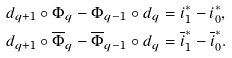<formula> <loc_0><loc_0><loc_500><loc_500>d _ { q + 1 } \circ \Phi _ { q } - \Phi _ { q - 1 } \circ d _ { q } & = i _ { 1 } ^ { \ast } - i _ { 0 } ^ { \ast } , \\ d _ { q + 1 } \circ \overline { \Phi } _ { q } - \overline { \Phi } _ { q - 1 } \circ d _ { q } & = \overline { i } _ { 1 } ^ { \ast } - \overline { i } _ { 0 } ^ { \ast } .</formula> 